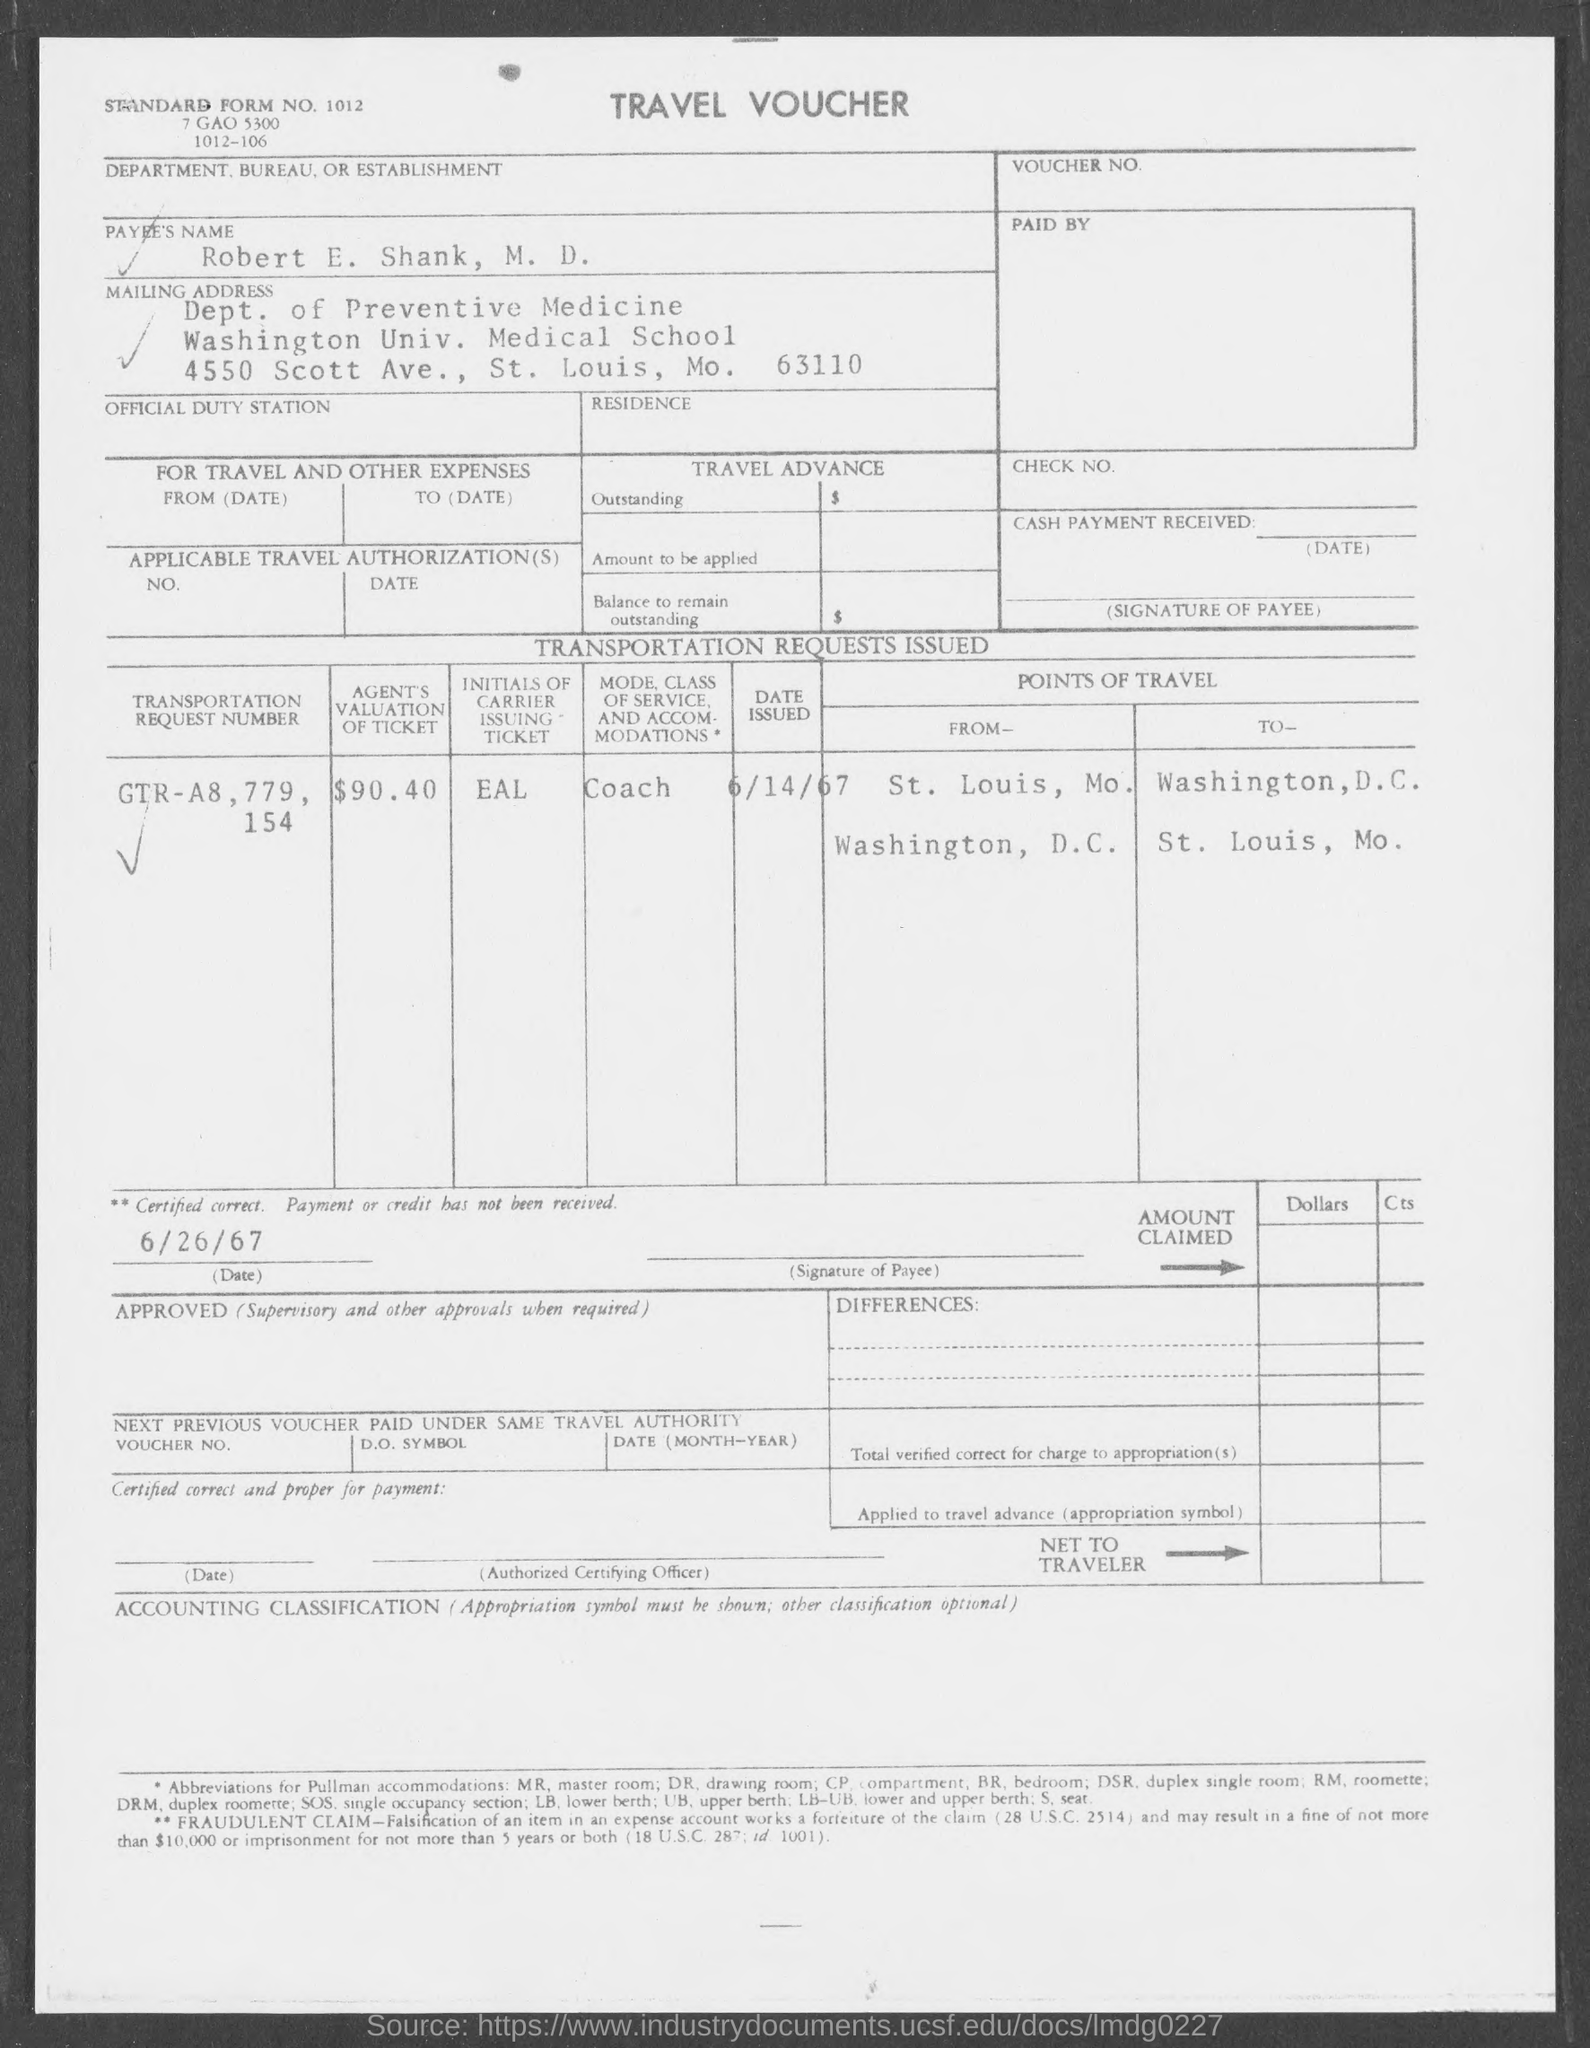List a handful of essential elements in this visual. What is the standard form number?" is the question being asked. Washington University Medical School is located in Saint Louis. 